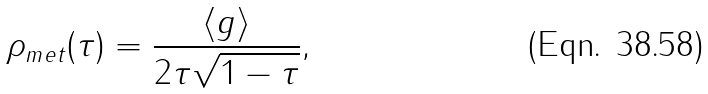<formula> <loc_0><loc_0><loc_500><loc_500>\rho _ { m e t } ( \tau ) = \frac { \left < g \right > } { 2 \tau \sqrt { 1 - \tau } } ,</formula> 